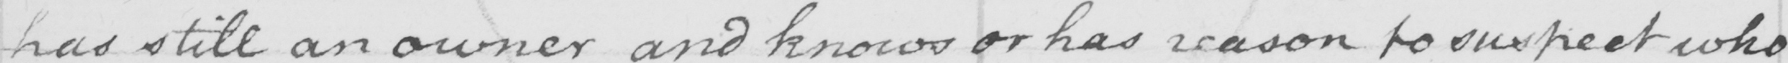What is written in this line of handwriting? has still an owner and knows or has reason to suspect who 